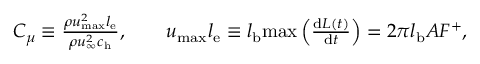<formula> <loc_0><loc_0><loc_500><loc_500>\begin{array} { r } { C _ { \mu } \equiv \frac { \rho u _ { \max } ^ { 2 } l _ { e } } { \rho u _ { \infty } ^ { 2 } c _ { h } } , \quad u _ { \max } l _ { e } \equiv l _ { b } \max \left ( \frac { d L ( t ) } { d t } \right ) = 2 \pi l _ { b } A F ^ { + } , } \end{array}</formula> 